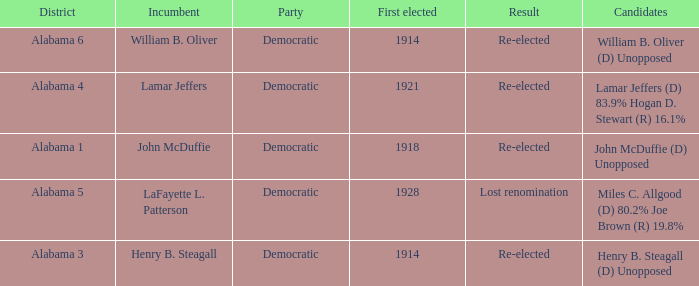How many in lost renomination results were elected first? 1928.0. 